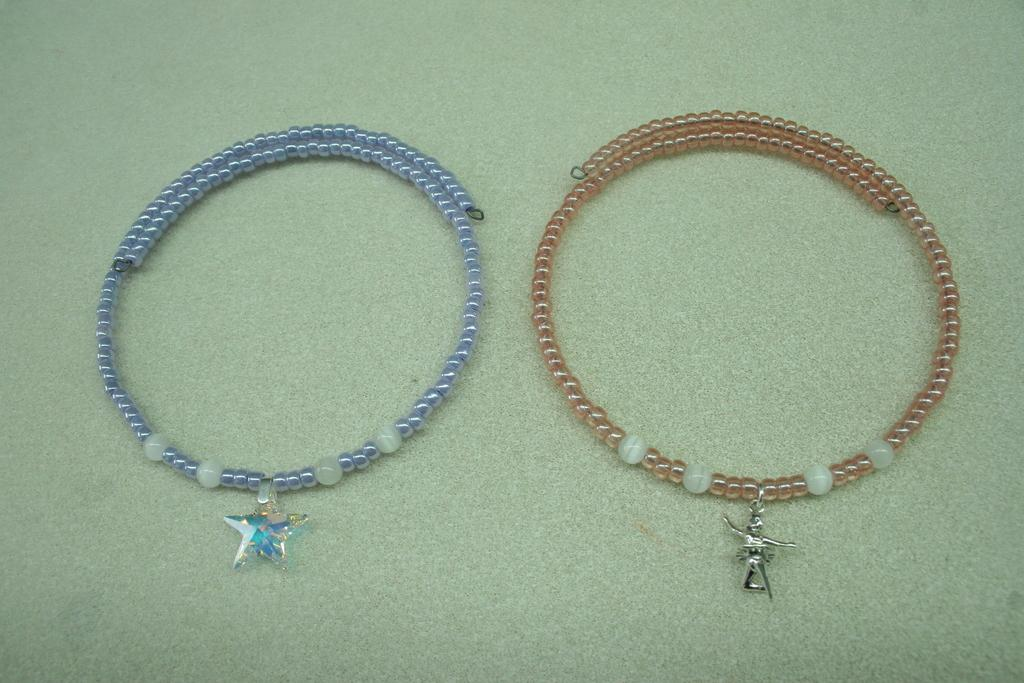What type of object can be seen in the background of the image? There is a jewel in the background of the image. Can you describe the color scheme of the image? The color green is present in the image. How much fuel is required to power the lake in the image? There is no lake present in the image, so the question of fuel requirements is not applicable. 